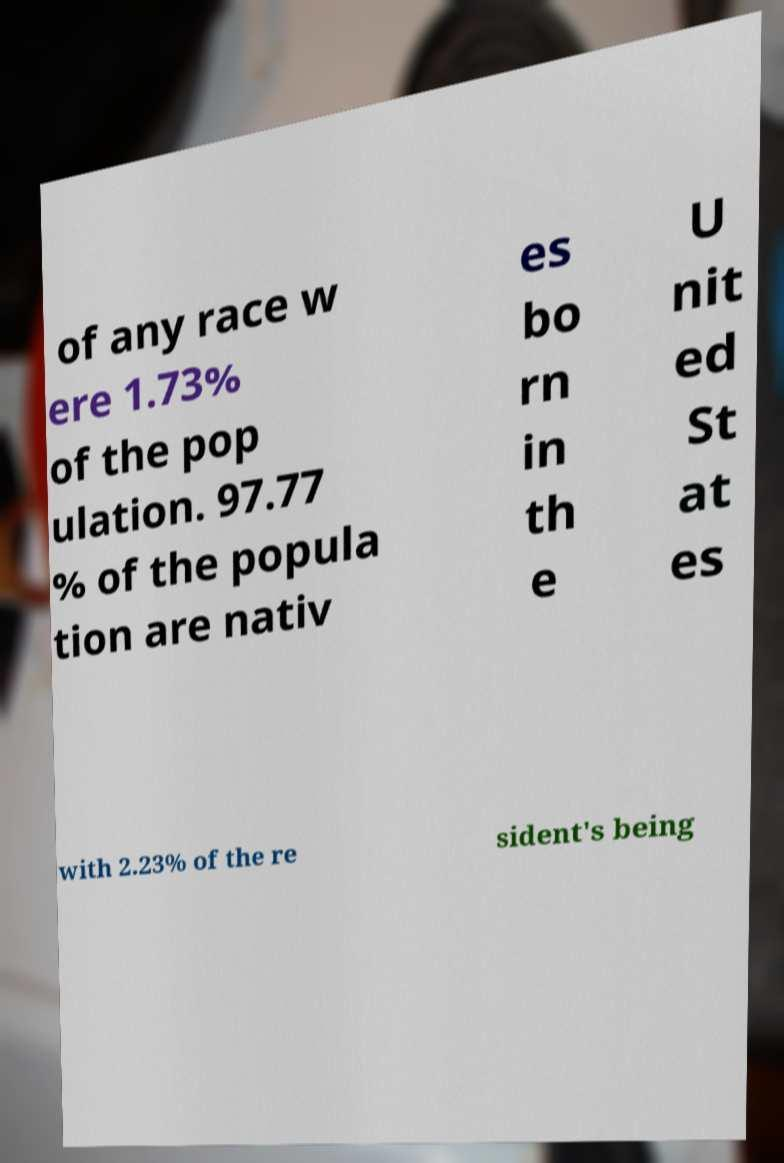I need the written content from this picture converted into text. Can you do that? of any race w ere 1.73% of the pop ulation. 97.77 % of the popula tion are nativ es bo rn in th e U nit ed St at es with 2.23% of the re sident's being 